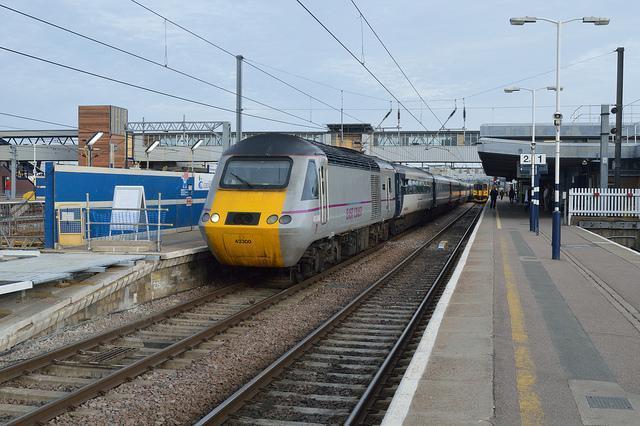How many poles are blue?
Give a very brief answer. 2. 